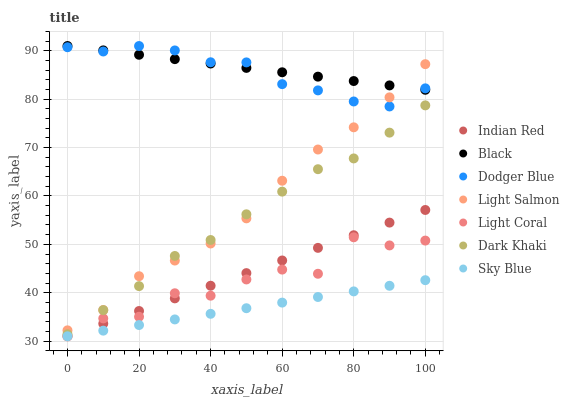Does Sky Blue have the minimum area under the curve?
Answer yes or no. Yes. Does Black have the maximum area under the curve?
Answer yes or no. Yes. Does Light Salmon have the minimum area under the curve?
Answer yes or no. No. Does Light Salmon have the maximum area under the curve?
Answer yes or no. No. Is Sky Blue the smoothest?
Answer yes or no. Yes. Is Light Coral the roughest?
Answer yes or no. Yes. Is Light Salmon the smoothest?
Answer yes or no. No. Is Light Salmon the roughest?
Answer yes or no. No. Does Light Coral have the lowest value?
Answer yes or no. Yes. Does Light Salmon have the lowest value?
Answer yes or no. No. Does Black have the highest value?
Answer yes or no. Yes. Does Light Salmon have the highest value?
Answer yes or no. No. Is Light Coral less than Dark Khaki?
Answer yes or no. Yes. Is Black greater than Light Coral?
Answer yes or no. Yes. Does Sky Blue intersect Indian Red?
Answer yes or no. Yes. Is Sky Blue less than Indian Red?
Answer yes or no. No. Is Sky Blue greater than Indian Red?
Answer yes or no. No. Does Light Coral intersect Dark Khaki?
Answer yes or no. No. 